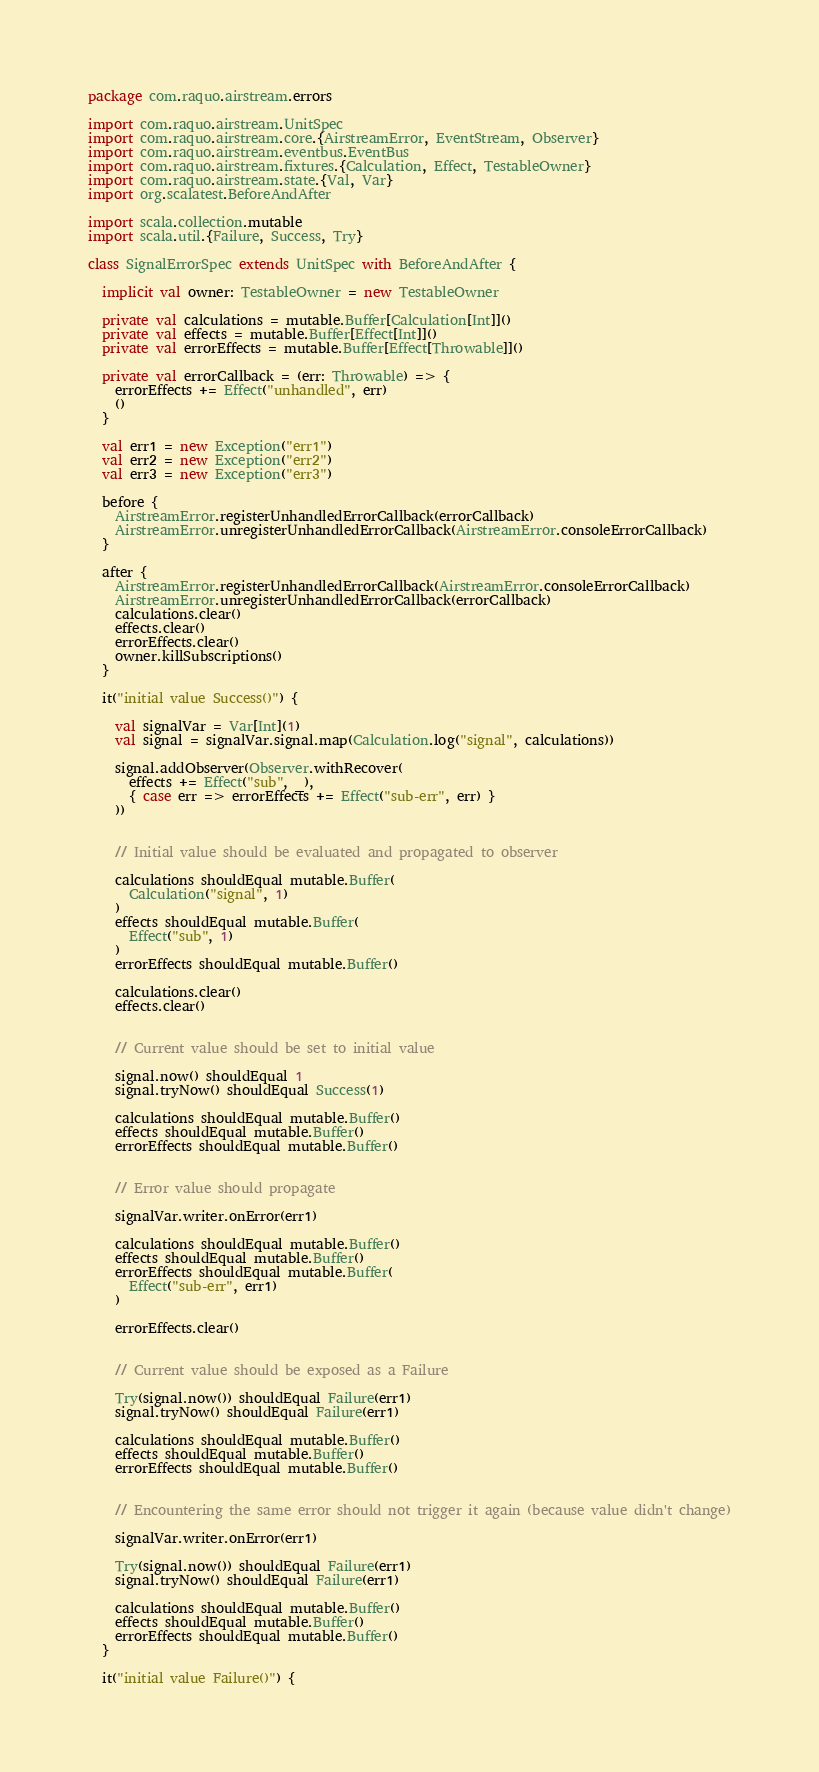Convert code to text. <code><loc_0><loc_0><loc_500><loc_500><_Scala_>package com.raquo.airstream.errors

import com.raquo.airstream.UnitSpec
import com.raquo.airstream.core.{AirstreamError, EventStream, Observer}
import com.raquo.airstream.eventbus.EventBus
import com.raquo.airstream.fixtures.{Calculation, Effect, TestableOwner}
import com.raquo.airstream.state.{Val, Var}
import org.scalatest.BeforeAndAfter

import scala.collection.mutable
import scala.util.{Failure, Success, Try}

class SignalErrorSpec extends UnitSpec with BeforeAndAfter {

  implicit val owner: TestableOwner = new TestableOwner

  private val calculations = mutable.Buffer[Calculation[Int]]()
  private val effects = mutable.Buffer[Effect[Int]]()
  private val errorEffects = mutable.Buffer[Effect[Throwable]]()

  private val errorCallback = (err: Throwable) => {
    errorEffects += Effect("unhandled", err)
    ()
  }

  val err1 = new Exception("err1")
  val err2 = new Exception("err2")
  val err3 = new Exception("err3")

  before {
    AirstreamError.registerUnhandledErrorCallback(errorCallback)
    AirstreamError.unregisterUnhandledErrorCallback(AirstreamError.consoleErrorCallback)
  }

  after {
    AirstreamError.registerUnhandledErrorCallback(AirstreamError.consoleErrorCallback)
    AirstreamError.unregisterUnhandledErrorCallback(errorCallback)
    calculations.clear()
    effects.clear()
    errorEffects.clear()
    owner.killSubscriptions()
  }

  it("initial value Success()") {

    val signalVar = Var[Int](1)
    val signal = signalVar.signal.map(Calculation.log("signal", calculations))

    signal.addObserver(Observer.withRecover(
      effects += Effect("sub", _),
      { case err => errorEffects += Effect("sub-err", err) }
    ))


    // Initial value should be evaluated and propagated to observer

    calculations shouldEqual mutable.Buffer(
      Calculation("signal", 1)
    )
    effects shouldEqual mutable.Buffer(
      Effect("sub", 1)
    )
    errorEffects shouldEqual mutable.Buffer()

    calculations.clear()
    effects.clear()


    // Current value should be set to initial value

    signal.now() shouldEqual 1
    signal.tryNow() shouldEqual Success(1)

    calculations shouldEqual mutable.Buffer()
    effects shouldEqual mutable.Buffer()
    errorEffects shouldEqual mutable.Buffer()


    // Error value should propagate

    signalVar.writer.onError(err1)

    calculations shouldEqual mutable.Buffer()
    effects shouldEqual mutable.Buffer()
    errorEffects shouldEqual mutable.Buffer(
      Effect("sub-err", err1)
    )

    errorEffects.clear()


    // Current value should be exposed as a Failure

    Try(signal.now()) shouldEqual Failure(err1)
    signal.tryNow() shouldEqual Failure(err1)

    calculations shouldEqual mutable.Buffer()
    effects shouldEqual mutable.Buffer()
    errorEffects shouldEqual mutable.Buffer()


    // Encountering the same error should not trigger it again (because value didn't change)

    signalVar.writer.onError(err1)

    Try(signal.now()) shouldEqual Failure(err1)
    signal.tryNow() shouldEqual Failure(err1)

    calculations shouldEqual mutable.Buffer()
    effects shouldEqual mutable.Buffer()
    errorEffects shouldEqual mutable.Buffer()
  }

  it("initial value Failure()") {
</code> 